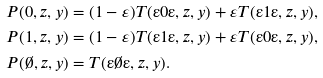Convert formula to latex. <formula><loc_0><loc_0><loc_500><loc_500>& P ( 0 , z , y ) = ( 1 - \varepsilon ) T ( " 0 " , z , y ) + \varepsilon T ( " 1 " , z , y ) , \\ & P ( 1 , z , y ) = ( 1 - \varepsilon ) T ( " 1 " , z , y ) + \varepsilon T ( " 0 " , z , y ) , \\ & P ( \emptyset , z , y ) = T ( " \emptyset " , z , y ) .</formula> 